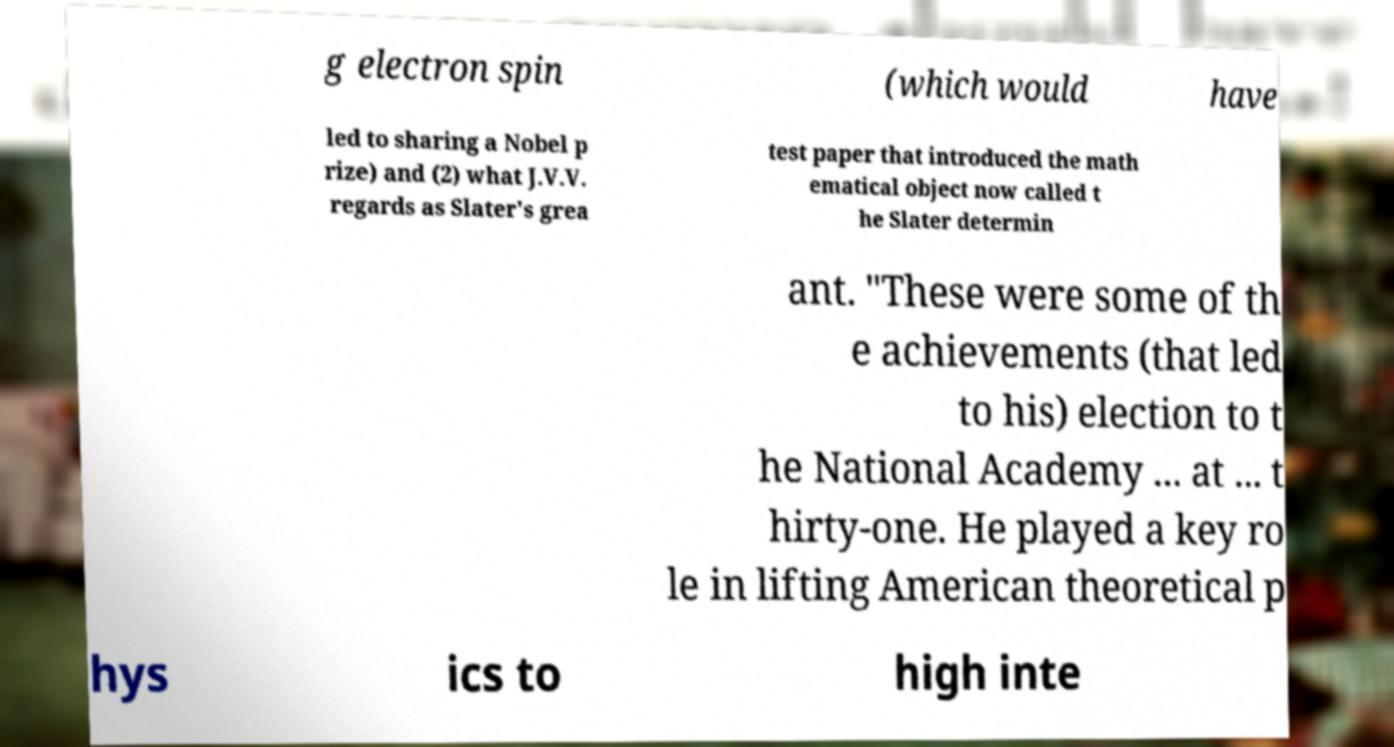For documentation purposes, I need the text within this image transcribed. Could you provide that? g electron spin (which would have led to sharing a Nobel p rize) and (2) what J.V.V. regards as Slater's grea test paper that introduced the math ematical object now called t he Slater determin ant. "These were some of th e achievements (that led to his) election to t he National Academy ... at ... t hirty-one. He played a key ro le in lifting American theoretical p hys ics to high inte 